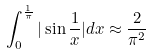<formula> <loc_0><loc_0><loc_500><loc_500>\int _ { 0 } ^ { \frac { 1 } { \pi } } | \sin \frac { 1 } { x } | d x \approx \frac { 2 } { \pi ^ { 2 } }</formula> 